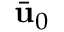Convert formula to latex. <formula><loc_0><loc_0><loc_500><loc_500>\bar { u } _ { 0 }</formula> 